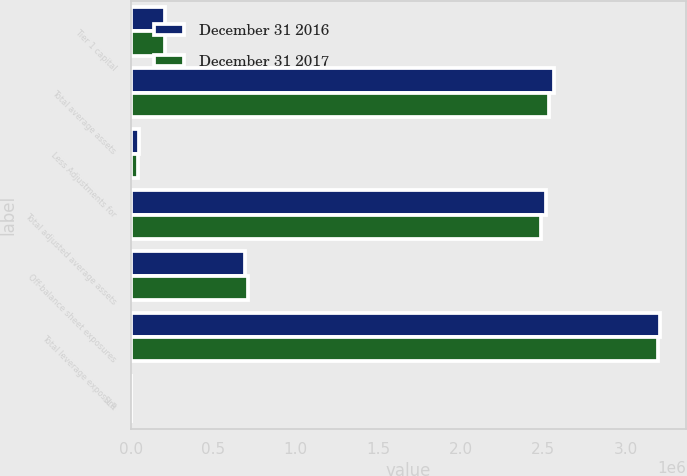<chart> <loc_0><loc_0><loc_500><loc_500><stacked_bar_chart><ecel><fcel>Tier 1 capital<fcel>Total average assets<fcel>Less Adjustments for<fcel>Total adjusted average assets<fcel>Off-balance sheet exposures<fcel>Total leverage exposure<fcel>SLR<nl><fcel>December 31 2016<fcel>208564<fcel>2.56216e+06<fcel>47333<fcel>2.51482e+06<fcel>690193<fcel>3.20502e+06<fcel>6.5<nl><fcel>December 31 2017<fcel>207474<fcel>2.53246e+06<fcel>46977<fcel>2.48548e+06<fcel>707359<fcel>3.19284e+06<fcel>6.5<nl></chart> 